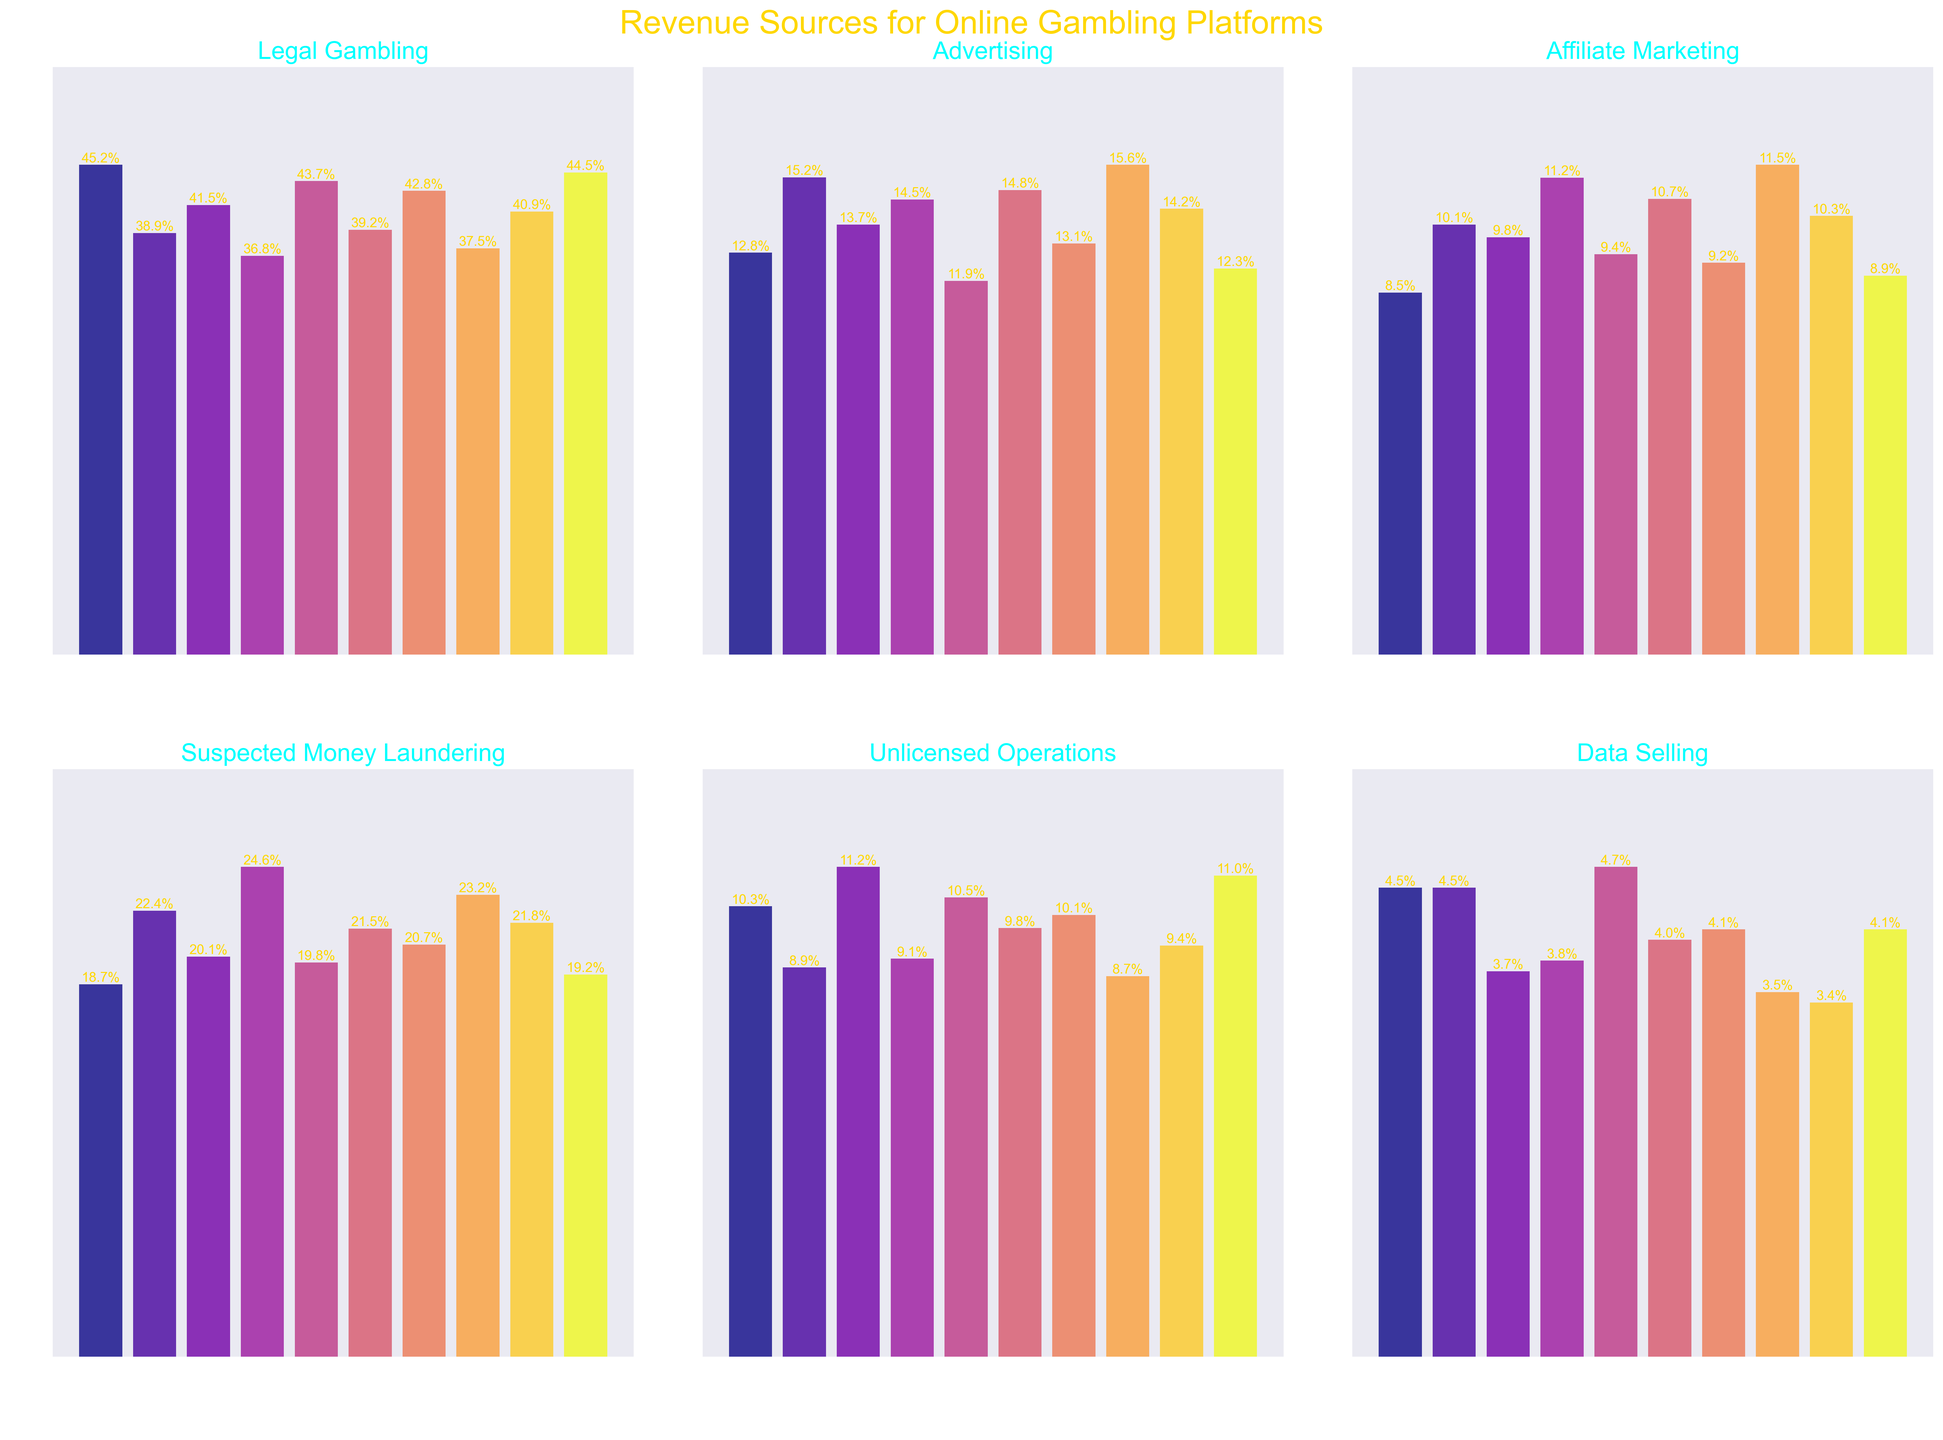Which platform has the highest percentage of suspected money laundering revenue? By observing the suspect money laundering subplot, we see that RoyalFlush has the highest bar.
Answer: RoyalFlush Which category has the smallest range in revenue percentages across all platforms? The category with the smallest range will have the least difference between the highest and lowest values. Observing all subplots, it's evident that 'Data Selling' has the smallest variance in heights.
Answer: Data Selling What's the combined revenue percentage of MegaBet from Suspected Money Laundering and Unlicensed Operations? Look at the subplot bars for MegaBet under 'Suspected Money Laundering' (18.7) and 'Unlicensed Operations' (10.3). Summing these values: 18.7 + 10.3 = 29.0
Answer: 29.0 Which platform generates the least revenue from Legal Gambling? By observing the Legal Gambling subplot, the shortest bar corresponds to RoyalFlush.
Answer: RoyalFlush How much more revenue does LuckyStrike generate from Suspected Money Laundering than from Data Selling? From the respective subplots, LuckyStrike has 22.4% revenue from Suspected Money Laundering and 4.5% from Data Selling. The difference is 22.4 - 4.5 = 17.9
Answer: 17.9 In the Advertising category, which platform has the second highest revenue and what percentage is it? By examining the Advertising subplot, the second tallest bar belongs to VegasOnline at 15.6%.
Answer: VegasOnline, 15.6 What's the average revenue percentage for all platforms from Affiliate Marketing? Find the 'Affiliate Marketing' bars for all platforms and calculate the average of these values: (8.5 + 10.1 + 9.8 + 11.2 + 9.4 + 10.7 + 9.2 + 11.5 + 10.3 + 8.9)/10 = 9.96
Answer: 9.96 Which platform shows the most consistent (least variable) revenue across all categories? Consistency can be judged by observing the relative heights of bars in each subplot for a platform. MegaBet has relatively stable revenue percentages across different categories.
Answer: MegaBet What is the total percentage of revenue generated from Unlicensed Operations by GoldRush and BlackjackPro combined? Look at 'Unlicensed Operations': GoldRush (11.2%) and BlackjackPro (11.0%). Summing these values: 11.2 + 11.0 = 22.2
Answer: 22.2 Which revenue category contributes the most for AcesHigh, and what is this percentage? By examining the heights of bars in each subplot for AcesHigh, 'Legal Gambling' has the highest percentage of 43.7.
Answer: Legal Gambling, 43.7 